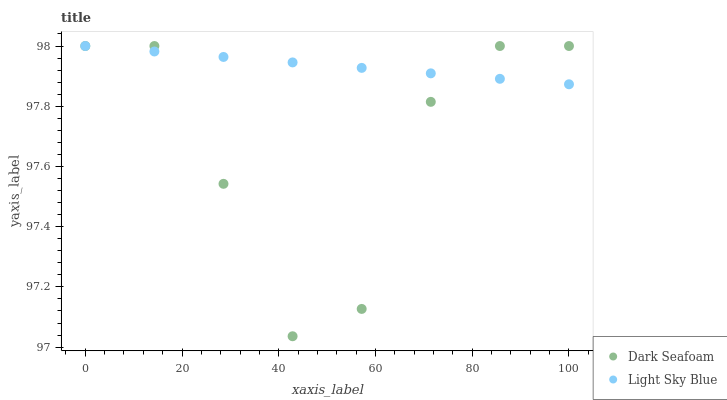Does Dark Seafoam have the minimum area under the curve?
Answer yes or no. Yes. Does Light Sky Blue have the maximum area under the curve?
Answer yes or no. Yes. Does Light Sky Blue have the minimum area under the curve?
Answer yes or no. No. Is Light Sky Blue the smoothest?
Answer yes or no. Yes. Is Dark Seafoam the roughest?
Answer yes or no. Yes. Is Light Sky Blue the roughest?
Answer yes or no. No. Does Dark Seafoam have the lowest value?
Answer yes or no. Yes. Does Light Sky Blue have the lowest value?
Answer yes or no. No. Does Light Sky Blue have the highest value?
Answer yes or no. Yes. Does Light Sky Blue intersect Dark Seafoam?
Answer yes or no. Yes. Is Light Sky Blue less than Dark Seafoam?
Answer yes or no. No. Is Light Sky Blue greater than Dark Seafoam?
Answer yes or no. No. 